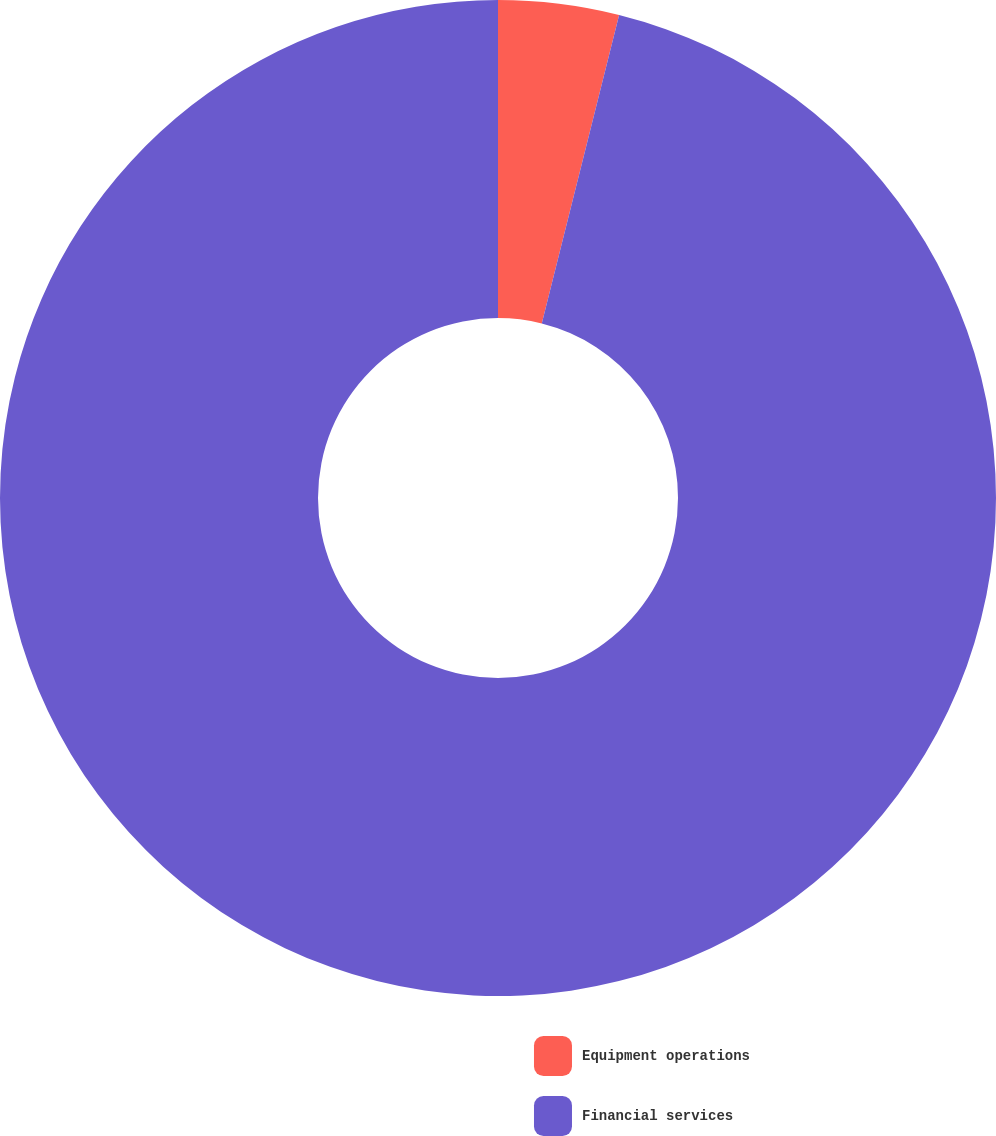Convert chart to OTSL. <chart><loc_0><loc_0><loc_500><loc_500><pie_chart><fcel>Equipment operations<fcel>Financial services<nl><fcel>3.91%<fcel>96.09%<nl></chart> 